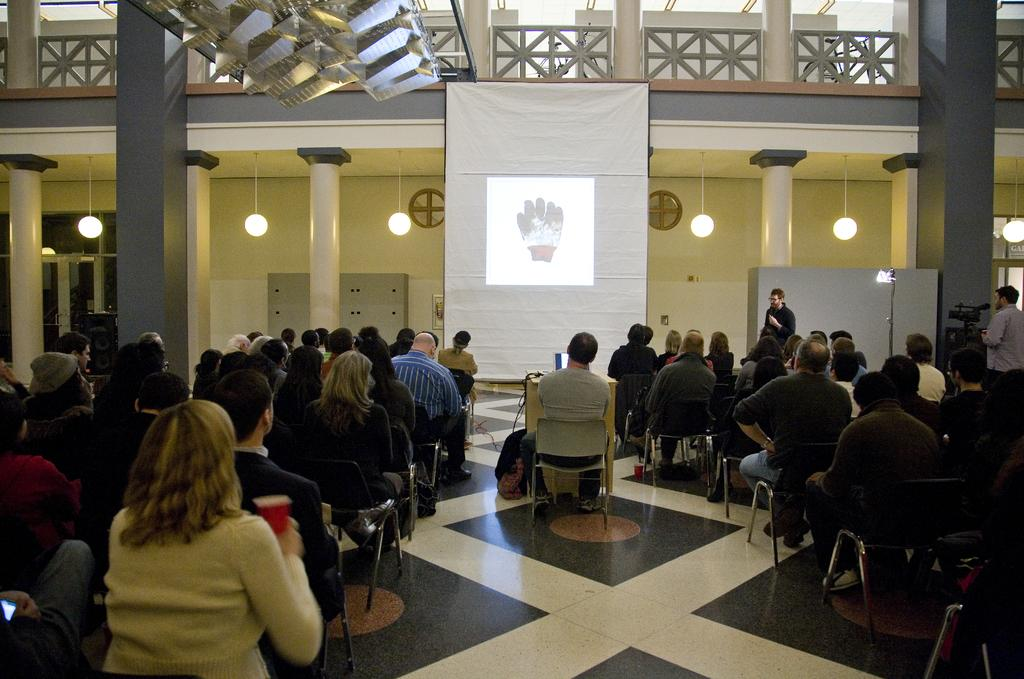How many people are in the image? There is a group of people in the image. What are the people doing in the image? The people are seated on chairs. What can be seen on the table in the image? There is a laptop on a table. What is the purpose of the projector screen in the image? The projector screen is likely used for displaying information or presentations. What is the man standing and speaking doing? The man is using a microphone to amplify his voice. How many cans of soda are visible in the image? There is no mention of cans of soda in the image; the facts provided do not include any information about cans or soda. 